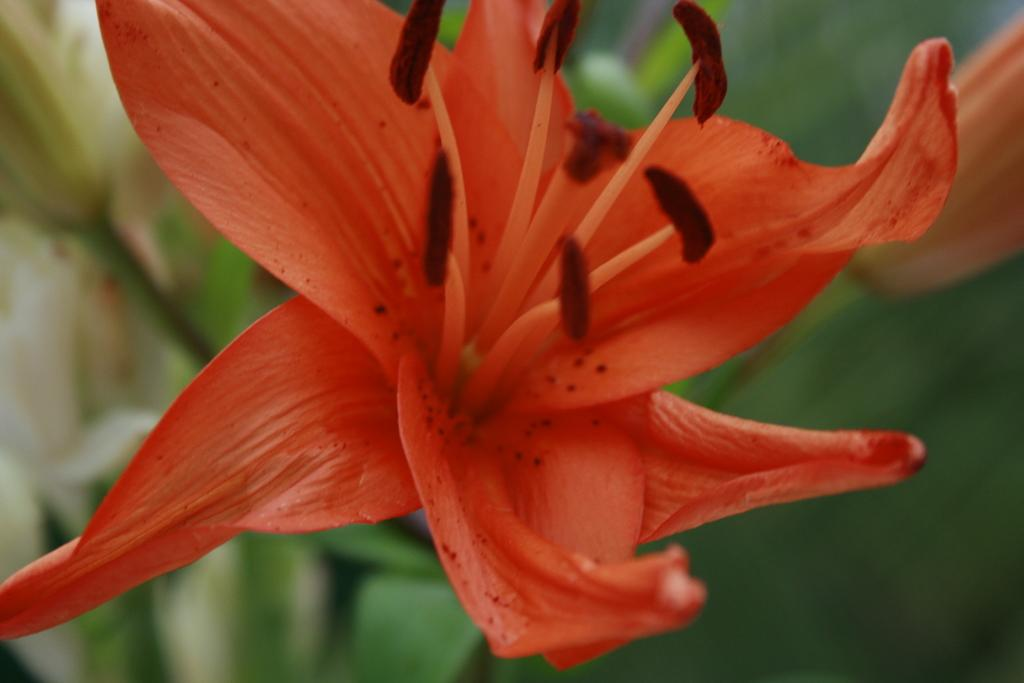What color is the flower on the plant in the image? The flower on the plant is orange. What can be found at the bottom of the plant? There are leaves at the bottom of the plant. Is there an earthquake happening in the image? No, there is no indication of an earthquake in the image. What type of flag is visible in the image? There is no flag present in the image. 